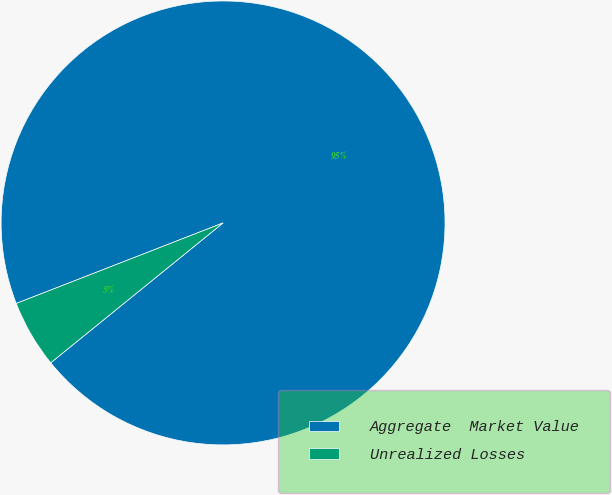Convert chart to OTSL. <chart><loc_0><loc_0><loc_500><loc_500><pie_chart><fcel>Aggregate  Market Value<fcel>Unrealized Losses<nl><fcel>95.06%<fcel>4.94%<nl></chart> 